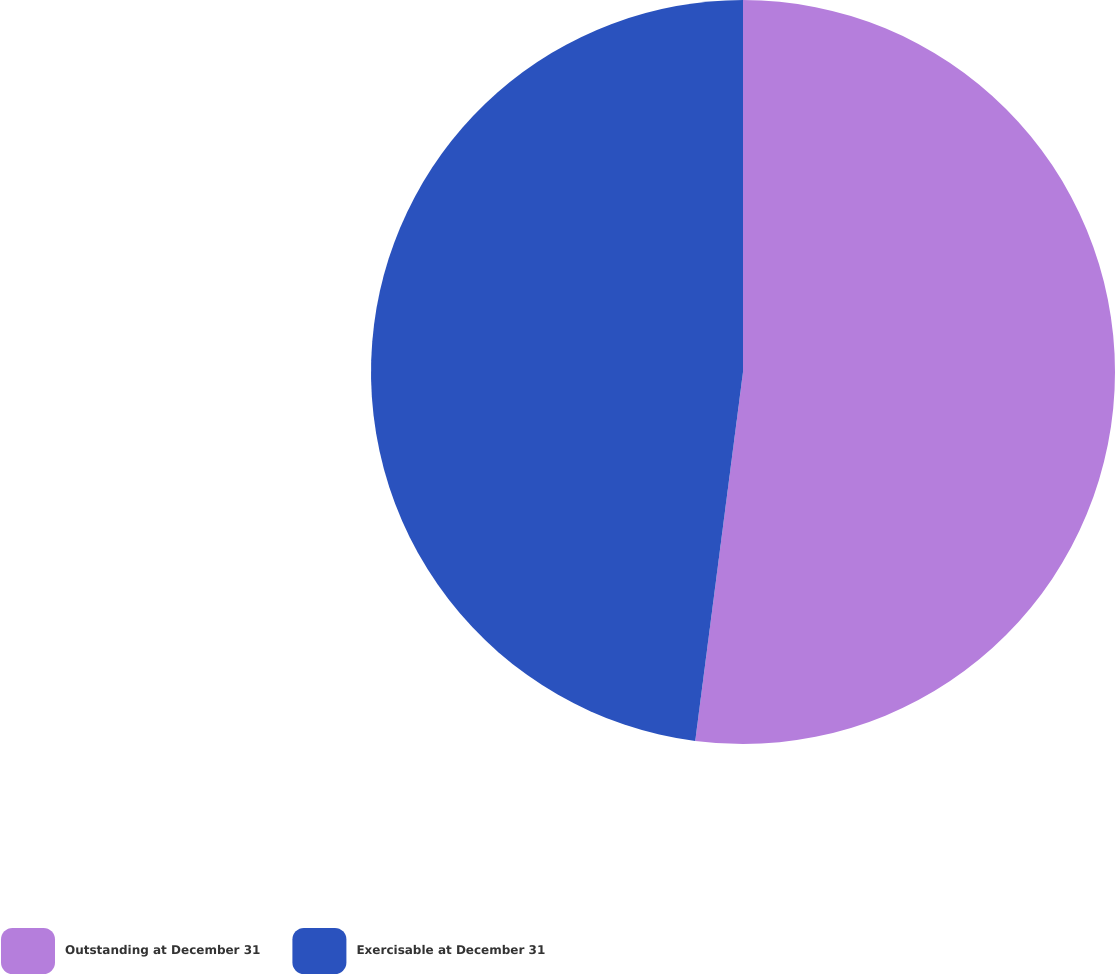Convert chart. <chart><loc_0><loc_0><loc_500><loc_500><pie_chart><fcel>Outstanding at December 31<fcel>Exercisable at December 31<nl><fcel>52.05%<fcel>47.95%<nl></chart> 